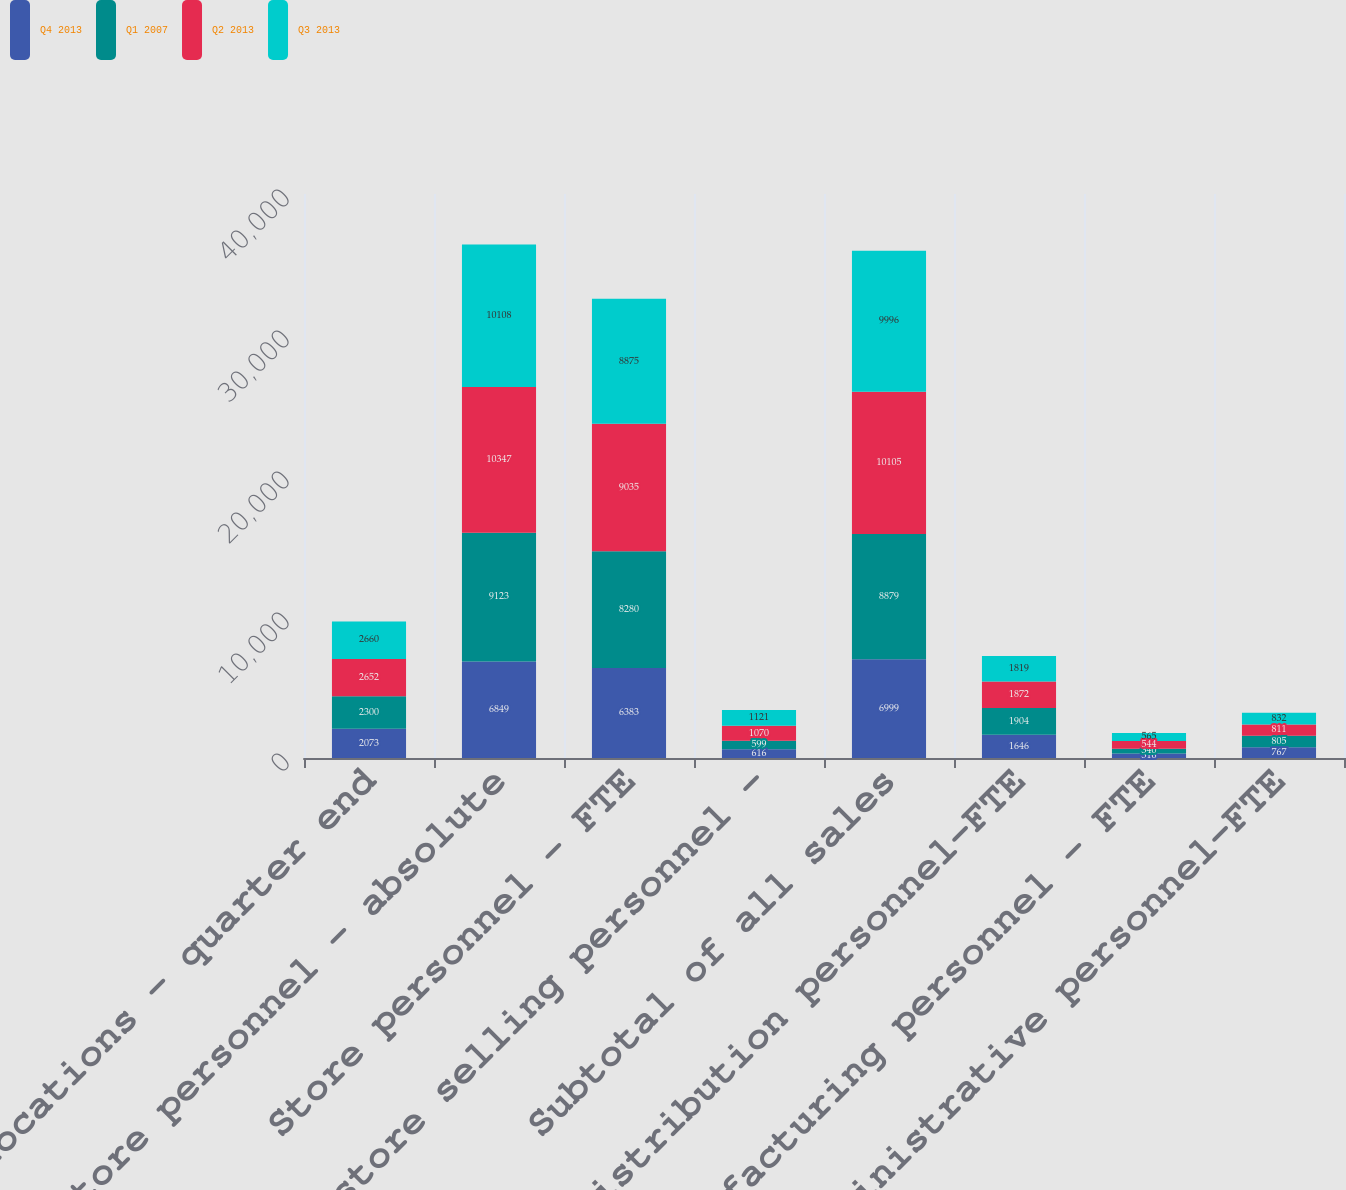<chart> <loc_0><loc_0><loc_500><loc_500><stacked_bar_chart><ecel><fcel>Store locations - quarter end<fcel>Store personnel - absolute<fcel>Store personnel - FTE<fcel>Non-store selling personnel -<fcel>Subtotal of all sales<fcel>Distribution personnel-FTE<fcel>Manufacturing personnel - FTE<fcel>Administrative personnel-FTE<nl><fcel>Q4 2013<fcel>2073<fcel>6849<fcel>6383<fcel>616<fcel>6999<fcel>1646<fcel>316<fcel>767<nl><fcel>Q1 2007<fcel>2300<fcel>9123<fcel>8280<fcel>599<fcel>8879<fcel>1904<fcel>340<fcel>805<nl><fcel>Q2 2013<fcel>2652<fcel>10347<fcel>9035<fcel>1070<fcel>10105<fcel>1872<fcel>544<fcel>811<nl><fcel>Q3 2013<fcel>2660<fcel>10108<fcel>8875<fcel>1121<fcel>9996<fcel>1819<fcel>565<fcel>832<nl></chart> 